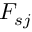Convert formula to latex. <formula><loc_0><loc_0><loc_500><loc_500>F _ { s j }</formula> 